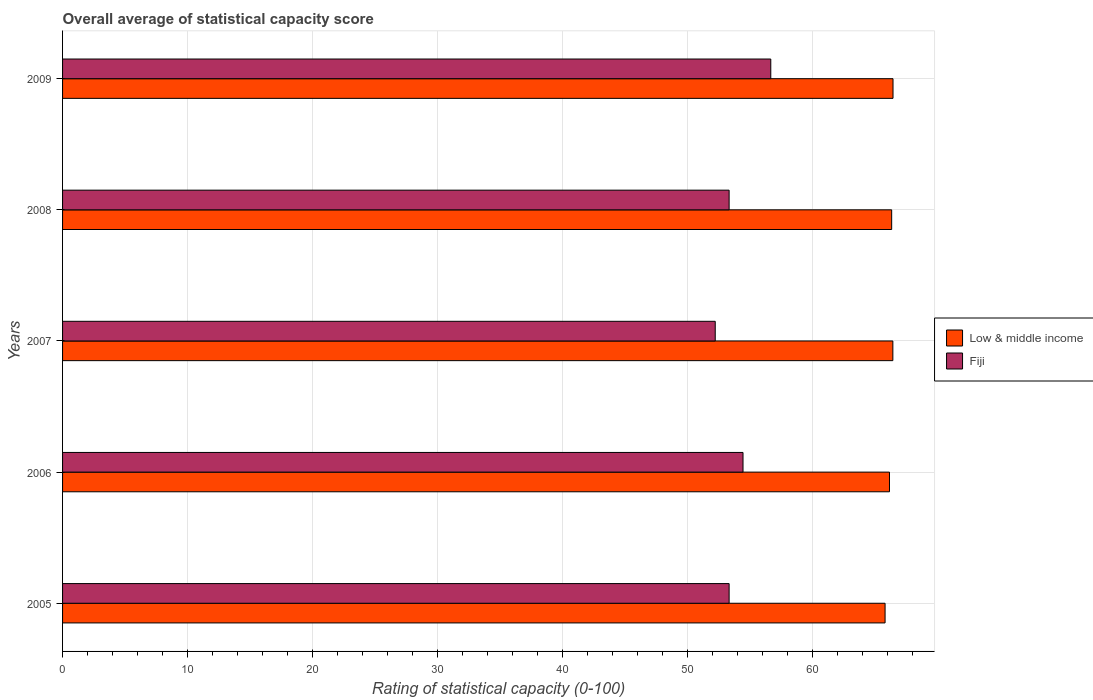How many different coloured bars are there?
Ensure brevity in your answer.  2. How many groups of bars are there?
Make the answer very short. 5. Are the number of bars per tick equal to the number of legend labels?
Your answer should be very brief. Yes. Are the number of bars on each tick of the Y-axis equal?
Offer a very short reply. Yes. How many bars are there on the 5th tick from the top?
Ensure brevity in your answer.  2. In how many cases, is the number of bars for a given year not equal to the number of legend labels?
Give a very brief answer. 0. What is the rating of statistical capacity in Fiji in 2008?
Your answer should be compact. 53.33. Across all years, what is the maximum rating of statistical capacity in Fiji?
Offer a very short reply. 56.67. Across all years, what is the minimum rating of statistical capacity in Fiji?
Your answer should be compact. 52.22. What is the total rating of statistical capacity in Low & middle income in the graph?
Make the answer very short. 331.2. What is the difference between the rating of statistical capacity in Fiji in 2005 and that in 2007?
Your answer should be very brief. 1.11. What is the difference between the rating of statistical capacity in Low & middle income in 2006 and the rating of statistical capacity in Fiji in 2007?
Your answer should be very brief. 13.94. What is the average rating of statistical capacity in Low & middle income per year?
Your answer should be very brief. 66.24. In the year 2007, what is the difference between the rating of statistical capacity in Fiji and rating of statistical capacity in Low & middle income?
Ensure brevity in your answer.  -14.21. In how many years, is the rating of statistical capacity in Fiji greater than 50 ?
Your response must be concise. 5. What is the ratio of the rating of statistical capacity in Fiji in 2005 to that in 2008?
Your response must be concise. 1. Is the rating of statistical capacity in Fiji in 2007 less than that in 2009?
Ensure brevity in your answer.  Yes. Is the difference between the rating of statistical capacity in Fiji in 2006 and 2009 greater than the difference between the rating of statistical capacity in Low & middle income in 2006 and 2009?
Provide a succinct answer. No. What is the difference between the highest and the second highest rating of statistical capacity in Fiji?
Provide a short and direct response. 2.22. What is the difference between the highest and the lowest rating of statistical capacity in Low & middle income?
Offer a very short reply. 0.63. In how many years, is the rating of statistical capacity in Low & middle income greater than the average rating of statistical capacity in Low & middle income taken over all years?
Make the answer very short. 3. What does the 1st bar from the top in 2006 represents?
Your answer should be very brief. Fiji. What does the 2nd bar from the bottom in 2006 represents?
Your response must be concise. Fiji. How many bars are there?
Keep it short and to the point. 10. What is the difference between two consecutive major ticks on the X-axis?
Provide a short and direct response. 10. Are the values on the major ticks of X-axis written in scientific E-notation?
Offer a terse response. No. Does the graph contain any zero values?
Provide a succinct answer. No. How are the legend labels stacked?
Offer a terse response. Vertical. What is the title of the graph?
Your answer should be very brief. Overall average of statistical capacity score. Does "Madagascar" appear as one of the legend labels in the graph?
Keep it short and to the point. No. What is the label or title of the X-axis?
Offer a terse response. Rating of statistical capacity (0-100). What is the label or title of the Y-axis?
Give a very brief answer. Years. What is the Rating of statistical capacity (0-100) of Low & middle income in 2005?
Provide a short and direct response. 65.81. What is the Rating of statistical capacity (0-100) in Fiji in 2005?
Give a very brief answer. 53.33. What is the Rating of statistical capacity (0-100) in Low & middle income in 2006?
Your answer should be very brief. 66.16. What is the Rating of statistical capacity (0-100) in Fiji in 2006?
Your answer should be compact. 54.44. What is the Rating of statistical capacity (0-100) of Low & middle income in 2007?
Provide a short and direct response. 66.43. What is the Rating of statistical capacity (0-100) of Fiji in 2007?
Your answer should be compact. 52.22. What is the Rating of statistical capacity (0-100) of Low & middle income in 2008?
Ensure brevity in your answer.  66.34. What is the Rating of statistical capacity (0-100) in Fiji in 2008?
Give a very brief answer. 53.33. What is the Rating of statistical capacity (0-100) in Low & middle income in 2009?
Your answer should be compact. 66.45. What is the Rating of statistical capacity (0-100) in Fiji in 2009?
Provide a succinct answer. 56.67. Across all years, what is the maximum Rating of statistical capacity (0-100) of Low & middle income?
Provide a succinct answer. 66.45. Across all years, what is the maximum Rating of statistical capacity (0-100) of Fiji?
Offer a very short reply. 56.67. Across all years, what is the minimum Rating of statistical capacity (0-100) of Low & middle income?
Your answer should be very brief. 65.81. Across all years, what is the minimum Rating of statistical capacity (0-100) in Fiji?
Your answer should be very brief. 52.22. What is the total Rating of statistical capacity (0-100) of Low & middle income in the graph?
Your answer should be very brief. 331.2. What is the total Rating of statistical capacity (0-100) of Fiji in the graph?
Your answer should be very brief. 270. What is the difference between the Rating of statistical capacity (0-100) of Low & middle income in 2005 and that in 2006?
Offer a very short reply. -0.35. What is the difference between the Rating of statistical capacity (0-100) in Fiji in 2005 and that in 2006?
Offer a terse response. -1.11. What is the difference between the Rating of statistical capacity (0-100) of Low & middle income in 2005 and that in 2007?
Your answer should be compact. -0.62. What is the difference between the Rating of statistical capacity (0-100) in Low & middle income in 2005 and that in 2008?
Give a very brief answer. -0.53. What is the difference between the Rating of statistical capacity (0-100) of Fiji in 2005 and that in 2008?
Provide a short and direct response. 0. What is the difference between the Rating of statistical capacity (0-100) of Low & middle income in 2005 and that in 2009?
Provide a succinct answer. -0.63. What is the difference between the Rating of statistical capacity (0-100) of Low & middle income in 2006 and that in 2007?
Ensure brevity in your answer.  -0.27. What is the difference between the Rating of statistical capacity (0-100) of Fiji in 2006 and that in 2007?
Offer a very short reply. 2.22. What is the difference between the Rating of statistical capacity (0-100) in Low & middle income in 2006 and that in 2008?
Your answer should be compact. -0.17. What is the difference between the Rating of statistical capacity (0-100) in Fiji in 2006 and that in 2008?
Provide a short and direct response. 1.11. What is the difference between the Rating of statistical capacity (0-100) of Low & middle income in 2006 and that in 2009?
Give a very brief answer. -0.28. What is the difference between the Rating of statistical capacity (0-100) of Fiji in 2006 and that in 2009?
Give a very brief answer. -2.22. What is the difference between the Rating of statistical capacity (0-100) of Low & middle income in 2007 and that in 2008?
Your response must be concise. 0.1. What is the difference between the Rating of statistical capacity (0-100) in Fiji in 2007 and that in 2008?
Your answer should be very brief. -1.11. What is the difference between the Rating of statistical capacity (0-100) of Low & middle income in 2007 and that in 2009?
Make the answer very short. -0.01. What is the difference between the Rating of statistical capacity (0-100) in Fiji in 2007 and that in 2009?
Ensure brevity in your answer.  -4.44. What is the difference between the Rating of statistical capacity (0-100) of Low & middle income in 2008 and that in 2009?
Offer a terse response. -0.11. What is the difference between the Rating of statistical capacity (0-100) in Fiji in 2008 and that in 2009?
Make the answer very short. -3.33. What is the difference between the Rating of statistical capacity (0-100) in Low & middle income in 2005 and the Rating of statistical capacity (0-100) in Fiji in 2006?
Offer a very short reply. 11.37. What is the difference between the Rating of statistical capacity (0-100) of Low & middle income in 2005 and the Rating of statistical capacity (0-100) of Fiji in 2007?
Offer a terse response. 13.59. What is the difference between the Rating of statistical capacity (0-100) in Low & middle income in 2005 and the Rating of statistical capacity (0-100) in Fiji in 2008?
Give a very brief answer. 12.48. What is the difference between the Rating of statistical capacity (0-100) of Low & middle income in 2005 and the Rating of statistical capacity (0-100) of Fiji in 2009?
Make the answer very short. 9.15. What is the difference between the Rating of statistical capacity (0-100) of Low & middle income in 2006 and the Rating of statistical capacity (0-100) of Fiji in 2007?
Offer a terse response. 13.94. What is the difference between the Rating of statistical capacity (0-100) in Low & middle income in 2006 and the Rating of statistical capacity (0-100) in Fiji in 2008?
Provide a succinct answer. 12.83. What is the difference between the Rating of statistical capacity (0-100) of Low & middle income in 2006 and the Rating of statistical capacity (0-100) of Fiji in 2009?
Your answer should be compact. 9.5. What is the difference between the Rating of statistical capacity (0-100) in Low & middle income in 2007 and the Rating of statistical capacity (0-100) in Fiji in 2008?
Your response must be concise. 13.1. What is the difference between the Rating of statistical capacity (0-100) of Low & middle income in 2007 and the Rating of statistical capacity (0-100) of Fiji in 2009?
Keep it short and to the point. 9.77. What is the difference between the Rating of statistical capacity (0-100) in Low & middle income in 2008 and the Rating of statistical capacity (0-100) in Fiji in 2009?
Ensure brevity in your answer.  9.67. What is the average Rating of statistical capacity (0-100) of Low & middle income per year?
Ensure brevity in your answer.  66.24. In the year 2005, what is the difference between the Rating of statistical capacity (0-100) in Low & middle income and Rating of statistical capacity (0-100) in Fiji?
Your answer should be very brief. 12.48. In the year 2006, what is the difference between the Rating of statistical capacity (0-100) of Low & middle income and Rating of statistical capacity (0-100) of Fiji?
Your answer should be compact. 11.72. In the year 2007, what is the difference between the Rating of statistical capacity (0-100) in Low & middle income and Rating of statistical capacity (0-100) in Fiji?
Provide a short and direct response. 14.21. In the year 2008, what is the difference between the Rating of statistical capacity (0-100) in Low & middle income and Rating of statistical capacity (0-100) in Fiji?
Your response must be concise. 13.01. In the year 2009, what is the difference between the Rating of statistical capacity (0-100) of Low & middle income and Rating of statistical capacity (0-100) of Fiji?
Your answer should be compact. 9.78. What is the ratio of the Rating of statistical capacity (0-100) in Fiji in 2005 to that in 2006?
Keep it short and to the point. 0.98. What is the ratio of the Rating of statistical capacity (0-100) of Low & middle income in 2005 to that in 2007?
Your response must be concise. 0.99. What is the ratio of the Rating of statistical capacity (0-100) of Fiji in 2005 to that in 2007?
Your response must be concise. 1.02. What is the ratio of the Rating of statistical capacity (0-100) of Low & middle income in 2005 to that in 2009?
Provide a short and direct response. 0.99. What is the ratio of the Rating of statistical capacity (0-100) of Low & middle income in 2006 to that in 2007?
Ensure brevity in your answer.  1. What is the ratio of the Rating of statistical capacity (0-100) in Fiji in 2006 to that in 2007?
Provide a succinct answer. 1.04. What is the ratio of the Rating of statistical capacity (0-100) in Fiji in 2006 to that in 2008?
Make the answer very short. 1.02. What is the ratio of the Rating of statistical capacity (0-100) in Fiji in 2006 to that in 2009?
Give a very brief answer. 0.96. What is the ratio of the Rating of statistical capacity (0-100) in Fiji in 2007 to that in 2008?
Your answer should be very brief. 0.98. What is the ratio of the Rating of statistical capacity (0-100) in Fiji in 2007 to that in 2009?
Provide a succinct answer. 0.92. What is the ratio of the Rating of statistical capacity (0-100) in Low & middle income in 2008 to that in 2009?
Ensure brevity in your answer.  1. What is the difference between the highest and the second highest Rating of statistical capacity (0-100) of Low & middle income?
Ensure brevity in your answer.  0.01. What is the difference between the highest and the second highest Rating of statistical capacity (0-100) in Fiji?
Provide a succinct answer. 2.22. What is the difference between the highest and the lowest Rating of statistical capacity (0-100) of Low & middle income?
Your response must be concise. 0.63. What is the difference between the highest and the lowest Rating of statistical capacity (0-100) of Fiji?
Ensure brevity in your answer.  4.44. 